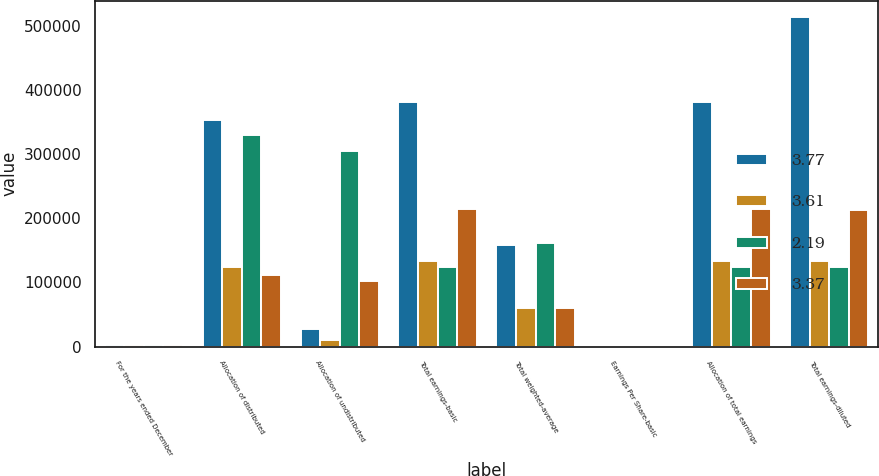Convert chart. <chart><loc_0><loc_0><loc_500><loc_500><stacked_bar_chart><ecel><fcel>For the years ended December<fcel>Allocation of distributed<fcel>Allocation of undistributed<fcel>Total earnings-basic<fcel>Total weighted-average<fcel>Earnings Per Share-basic<fcel>Allocation of total earnings<fcel>Total earnings-diluted<nl><fcel>3.77<fcel>2015<fcel>352953<fcel>27324<fcel>380277<fcel>158471<fcel>2.4<fcel>380277<fcel>512951<nl><fcel>3.61<fcel>2015<fcel>123179<fcel>9495<fcel>132674<fcel>60620<fcel>2.19<fcel>132674<fcel>132605<nl><fcel>2.19<fcel>2014<fcel>328752<fcel>303801<fcel>123179<fcel>161935<fcel>3.91<fcel>123179<fcel>123179<nl><fcel>3.37<fcel>2014<fcel>111662<fcel>102697<fcel>214359<fcel>60620<fcel>3.54<fcel>214359<fcel>213288<nl></chart> 